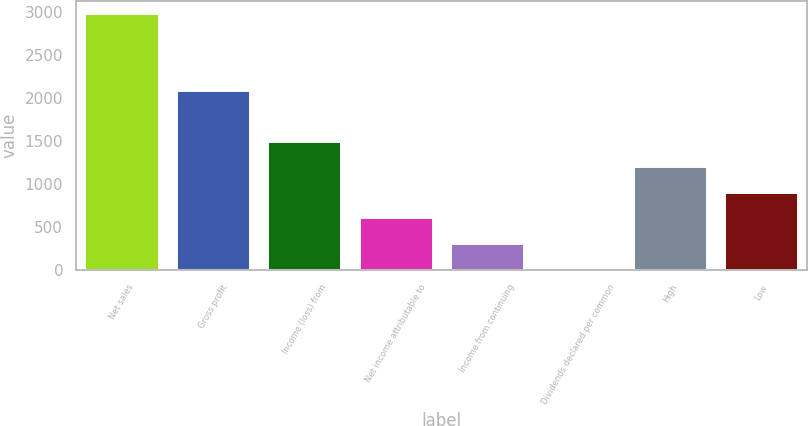Convert chart. <chart><loc_0><loc_0><loc_500><loc_500><bar_chart><fcel>Net sales<fcel>Gross profit<fcel>Income (loss) from<fcel>Net income attributable to<fcel>Income from continuing<fcel>Dividends declared per common<fcel>High<fcel>Low<nl><fcel>2978<fcel>2084.65<fcel>1489.09<fcel>595.75<fcel>297.97<fcel>0.19<fcel>1191.31<fcel>893.53<nl></chart> 